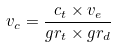<formula> <loc_0><loc_0><loc_500><loc_500>v _ { c } = \frac { c _ { t } \times v _ { e } } { g r _ { t } \times g r _ { d } }</formula> 